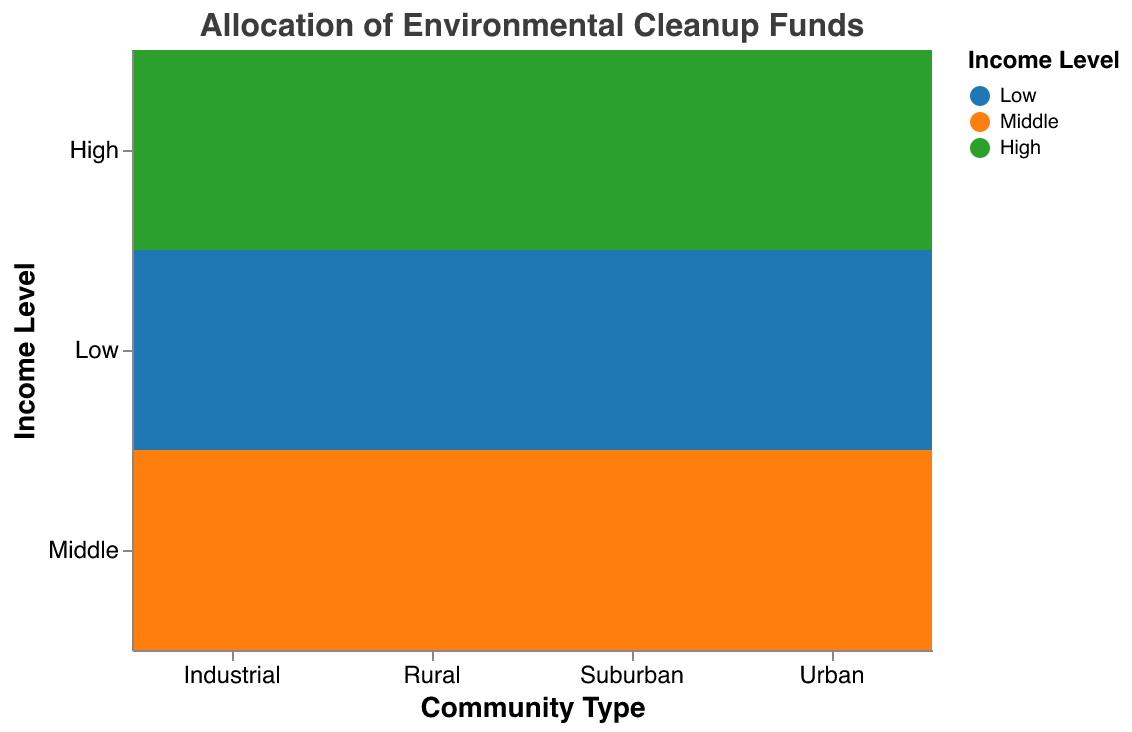what is the title of the plot? The title is typically found at the top of the figure. For this plot, it is specified as "Allocation of Environmental Cleanup Funds."
Answer: Allocation of Environmental Cleanup Funds Which community type received the highest total cleanup funds for low-income levels? To determine this, we look at the "Low" row and compare the cleanup funds across different community types. Industrial communities have the highest value (60).
Answer: Industrial How much more cleanup funds do low-income urban communities receive compared to high-income urban communities? To find this difference, subtract the funds allocated to high-income urban communities (15) from those allocated to low-income urban communities (45). 45 - 15 = 30
Answer: 30 Which community type has the smallest allocation of cleanup funds for middle-income levels? By examining the "Middle" row and comparing across community types, we see that rural communities have the smallest allocation (25).
Answer: Rural What is the total cleanup funds allocated to suburban communities? Sum the funds allocated to all income levels in suburban communities: 20 (Low) + 35 (Middle) + 40 (High). Hence, 20 + 35 + 40 = 95
Answer: 95 Do urban communities receive more cleanup funds for low-income or middle-income levels? Compare the values for urban communities at these two income levels (Low: 45, Middle: 30). Urban communities receive more for low-income levels.
Answer: Low-income levels What is the ratio of cleanup funds between high-income and low-income industrial communities? The funds for high-income industrial communities is 25, and for low-income industrial communities is 60. The ratio is 25:60, which simplifies to 5:12.
Answer: 5:12 Which community type has the most balanced allocation across all income levels (lowest relative variance)? By visually assessing the plot for equal-sized funding allocations across Low, Middle, and High income levels, suburban and rural communities appear fairly balanced. Both allocation differences are relatively low.
Answer: Suburban or Rural How much more total cleanup funds do industrial communities receive than rural communities? Sum the funds for all income levels in both community types: Industrial (60 + 40 + 25 = 125) and Rural (10 + 25 + 30 = 65). Then, subtract the total funds for rural from industrial communities: 125 - 65 = 60
Answer: 60 Which income level generally receives more cleanup funds across community types? By comparing rows, low-income levels generally receive more funds across most community types (Urban: 45, Industrial: 60), with some exceptions. Low-income consistently shows up with higher funds per community type.
Answer: Low-income 